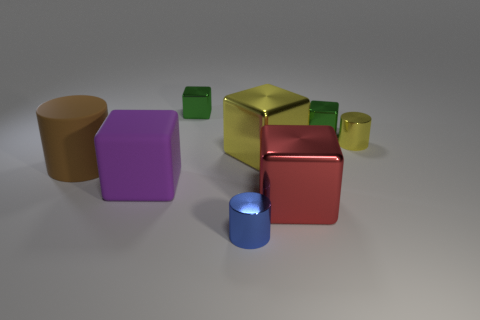Add 2 large cyan shiny things. How many objects exist? 10 Subtract all small metallic cubes. How many cubes are left? 3 Subtract all brown cylinders. How many cylinders are left? 2 Subtract 5 blocks. How many blocks are left? 0 Add 4 big brown cylinders. How many big brown cylinders are left? 5 Add 7 large cyan rubber balls. How many large cyan rubber balls exist? 7 Subtract 0 purple cylinders. How many objects are left? 8 Subtract all cubes. How many objects are left? 3 Subtract all cyan blocks. Subtract all purple cylinders. How many blocks are left? 5 Subtract all red spheres. How many yellow cylinders are left? 1 